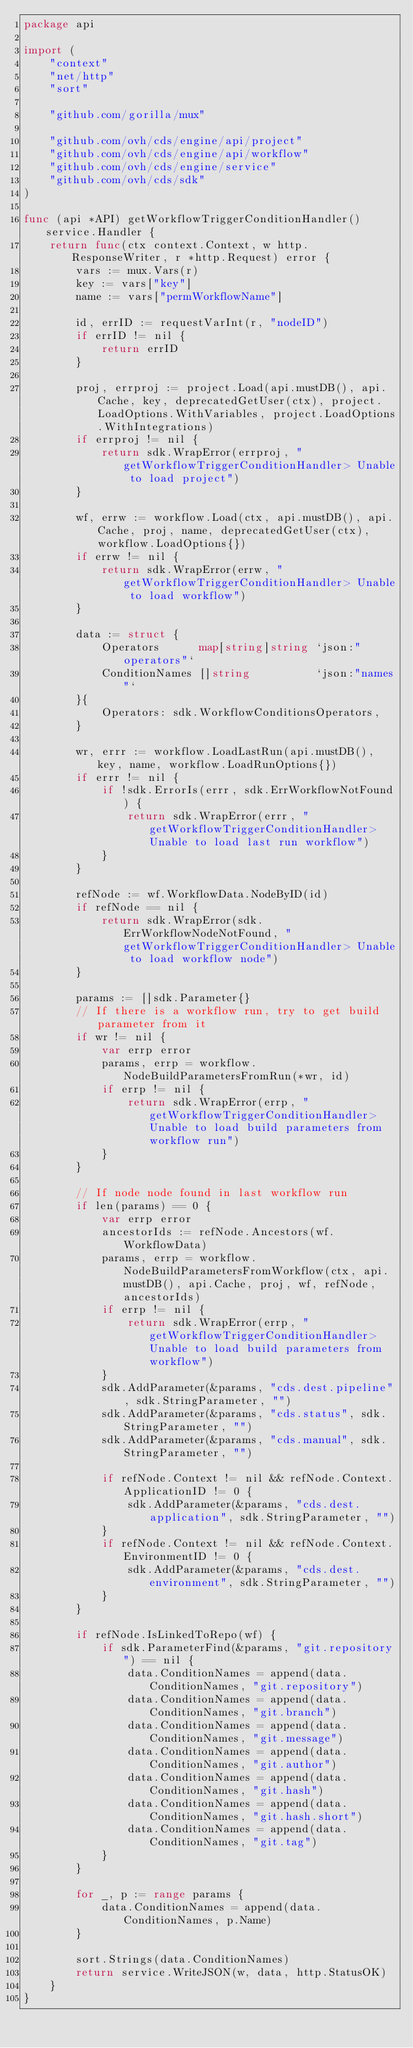Convert code to text. <code><loc_0><loc_0><loc_500><loc_500><_Go_>package api

import (
	"context"
	"net/http"
	"sort"

	"github.com/gorilla/mux"

	"github.com/ovh/cds/engine/api/project"
	"github.com/ovh/cds/engine/api/workflow"
	"github.com/ovh/cds/engine/service"
	"github.com/ovh/cds/sdk"
)

func (api *API) getWorkflowTriggerConditionHandler() service.Handler {
	return func(ctx context.Context, w http.ResponseWriter, r *http.Request) error {
		vars := mux.Vars(r)
		key := vars["key"]
		name := vars["permWorkflowName"]

		id, errID := requestVarInt(r, "nodeID")
		if errID != nil {
			return errID
		}

		proj, errproj := project.Load(api.mustDB(), api.Cache, key, deprecatedGetUser(ctx), project.LoadOptions.WithVariables, project.LoadOptions.WithIntegrations)
		if errproj != nil {
			return sdk.WrapError(errproj, "getWorkflowTriggerConditionHandler> Unable to load project")
		}

		wf, errw := workflow.Load(ctx, api.mustDB(), api.Cache, proj, name, deprecatedGetUser(ctx), workflow.LoadOptions{})
		if errw != nil {
			return sdk.WrapError(errw, "getWorkflowTriggerConditionHandler> Unable to load workflow")
		}

		data := struct {
			Operators      map[string]string `json:"operators"`
			ConditionNames []string          `json:"names"`
		}{
			Operators: sdk.WorkflowConditionsOperators,
		}

		wr, errr := workflow.LoadLastRun(api.mustDB(), key, name, workflow.LoadRunOptions{})
		if errr != nil {
			if !sdk.ErrorIs(errr, sdk.ErrWorkflowNotFound) {
				return sdk.WrapError(errr, "getWorkflowTriggerConditionHandler> Unable to load last run workflow")
			}
		}

		refNode := wf.WorkflowData.NodeByID(id)
		if refNode == nil {
			return sdk.WrapError(sdk.ErrWorkflowNodeNotFound, "getWorkflowTriggerConditionHandler> Unable to load workflow node")
		}

		params := []sdk.Parameter{}
		// If there is a workflow run, try to get build parameter from it
		if wr != nil {
			var errp error
			params, errp = workflow.NodeBuildParametersFromRun(*wr, id)
			if errp != nil {
				return sdk.WrapError(errp, "getWorkflowTriggerConditionHandler> Unable to load build parameters from workflow run")
			}
		}

		// If node node found in last workflow run
		if len(params) == 0 {
			var errp error
			ancestorIds := refNode.Ancestors(wf.WorkflowData)
			params, errp = workflow.NodeBuildParametersFromWorkflow(ctx, api.mustDB(), api.Cache, proj, wf, refNode, ancestorIds)
			if errp != nil {
				return sdk.WrapError(errp, "getWorkflowTriggerConditionHandler> Unable to load build parameters from workflow")
			}
			sdk.AddParameter(&params, "cds.dest.pipeline", sdk.StringParameter, "")
			sdk.AddParameter(&params, "cds.status", sdk.StringParameter, "")
			sdk.AddParameter(&params, "cds.manual", sdk.StringParameter, "")

			if refNode.Context != nil && refNode.Context.ApplicationID != 0 {
				sdk.AddParameter(&params, "cds.dest.application", sdk.StringParameter, "")
			}
			if refNode.Context != nil && refNode.Context.EnvironmentID != 0 {
				sdk.AddParameter(&params, "cds.dest.environment", sdk.StringParameter, "")
			}
		}

		if refNode.IsLinkedToRepo(wf) {
			if sdk.ParameterFind(&params, "git.repository") == nil {
				data.ConditionNames = append(data.ConditionNames, "git.repository")
				data.ConditionNames = append(data.ConditionNames, "git.branch")
				data.ConditionNames = append(data.ConditionNames, "git.message")
				data.ConditionNames = append(data.ConditionNames, "git.author")
				data.ConditionNames = append(data.ConditionNames, "git.hash")
				data.ConditionNames = append(data.ConditionNames, "git.hash.short")
				data.ConditionNames = append(data.ConditionNames, "git.tag")
			}
		}

		for _, p := range params {
			data.ConditionNames = append(data.ConditionNames, p.Name)
		}

		sort.Strings(data.ConditionNames)
		return service.WriteJSON(w, data, http.StatusOK)
	}
}
</code> 